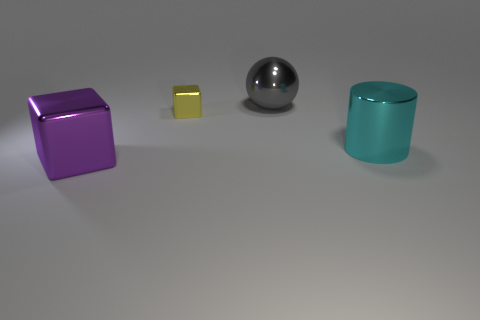What number of matte objects are big brown cubes or gray objects?
Provide a short and direct response. 0. Are there an equal number of large metal things that are on the left side of the large gray thing and large metal balls?
Make the answer very short. Yes. There is a big object in front of the big cylinder; are there any big cyan metallic cylinders to the right of it?
Provide a succinct answer. Yes. Is the yellow block made of the same material as the large purple object?
Keep it short and to the point. Yes. What is the shape of the metallic object that is in front of the small metallic thing and on the left side of the large gray shiny ball?
Your answer should be compact. Cube. What is the size of the metallic object to the right of the large metallic thing that is behind the big cyan metal thing?
Offer a terse response. Large. How many purple objects are the same shape as the yellow thing?
Provide a succinct answer. 1. Is there any other thing that is the same shape as the big gray metal thing?
Give a very brief answer. No. Does the ball to the right of the small metallic thing have the same material as the big thing in front of the cyan metal cylinder?
Provide a succinct answer. Yes. What is the color of the tiny metal block?
Provide a short and direct response. Yellow. 